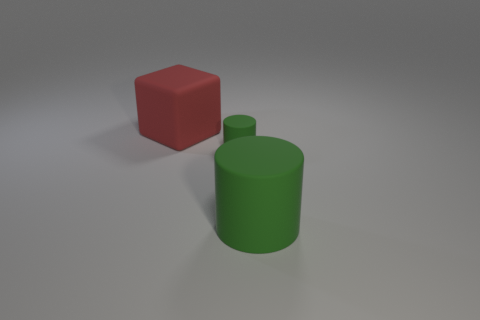Is the color of the large rubber cube the same as the small matte cylinder?
Keep it short and to the point. No. Is the number of green objects behind the small green rubber cylinder less than the number of large red matte objects on the left side of the large rubber cylinder?
Provide a succinct answer. Yes. There is a large rubber thing that is the same shape as the tiny green thing; what color is it?
Make the answer very short. Green. Is the number of large red things that are on the right side of the tiny green rubber object less than the number of small cyan cylinders?
Make the answer very short. No. Is there anything else that has the same size as the red block?
Your response must be concise. Yes. How big is the green rubber thing that is in front of the green cylinder that is behind the big cylinder?
Make the answer very short. Large. Are there any other things that are the same shape as the large red object?
Keep it short and to the point. No. Is the number of large rubber blocks less than the number of blue cylinders?
Ensure brevity in your answer.  No. What is the object that is left of the big matte cylinder and in front of the big red matte object made of?
Provide a succinct answer. Rubber. Is there a big rubber cylinder that is left of the large block that is to the left of the small matte thing?
Your response must be concise. No. 